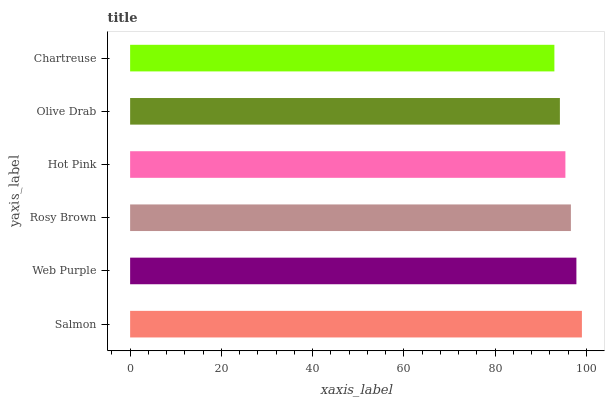Is Chartreuse the minimum?
Answer yes or no. Yes. Is Salmon the maximum?
Answer yes or no. Yes. Is Web Purple the minimum?
Answer yes or no. No. Is Web Purple the maximum?
Answer yes or no. No. Is Salmon greater than Web Purple?
Answer yes or no. Yes. Is Web Purple less than Salmon?
Answer yes or no. Yes. Is Web Purple greater than Salmon?
Answer yes or no. No. Is Salmon less than Web Purple?
Answer yes or no. No. Is Rosy Brown the high median?
Answer yes or no. Yes. Is Hot Pink the low median?
Answer yes or no. Yes. Is Salmon the high median?
Answer yes or no. No. Is Olive Drab the low median?
Answer yes or no. No. 